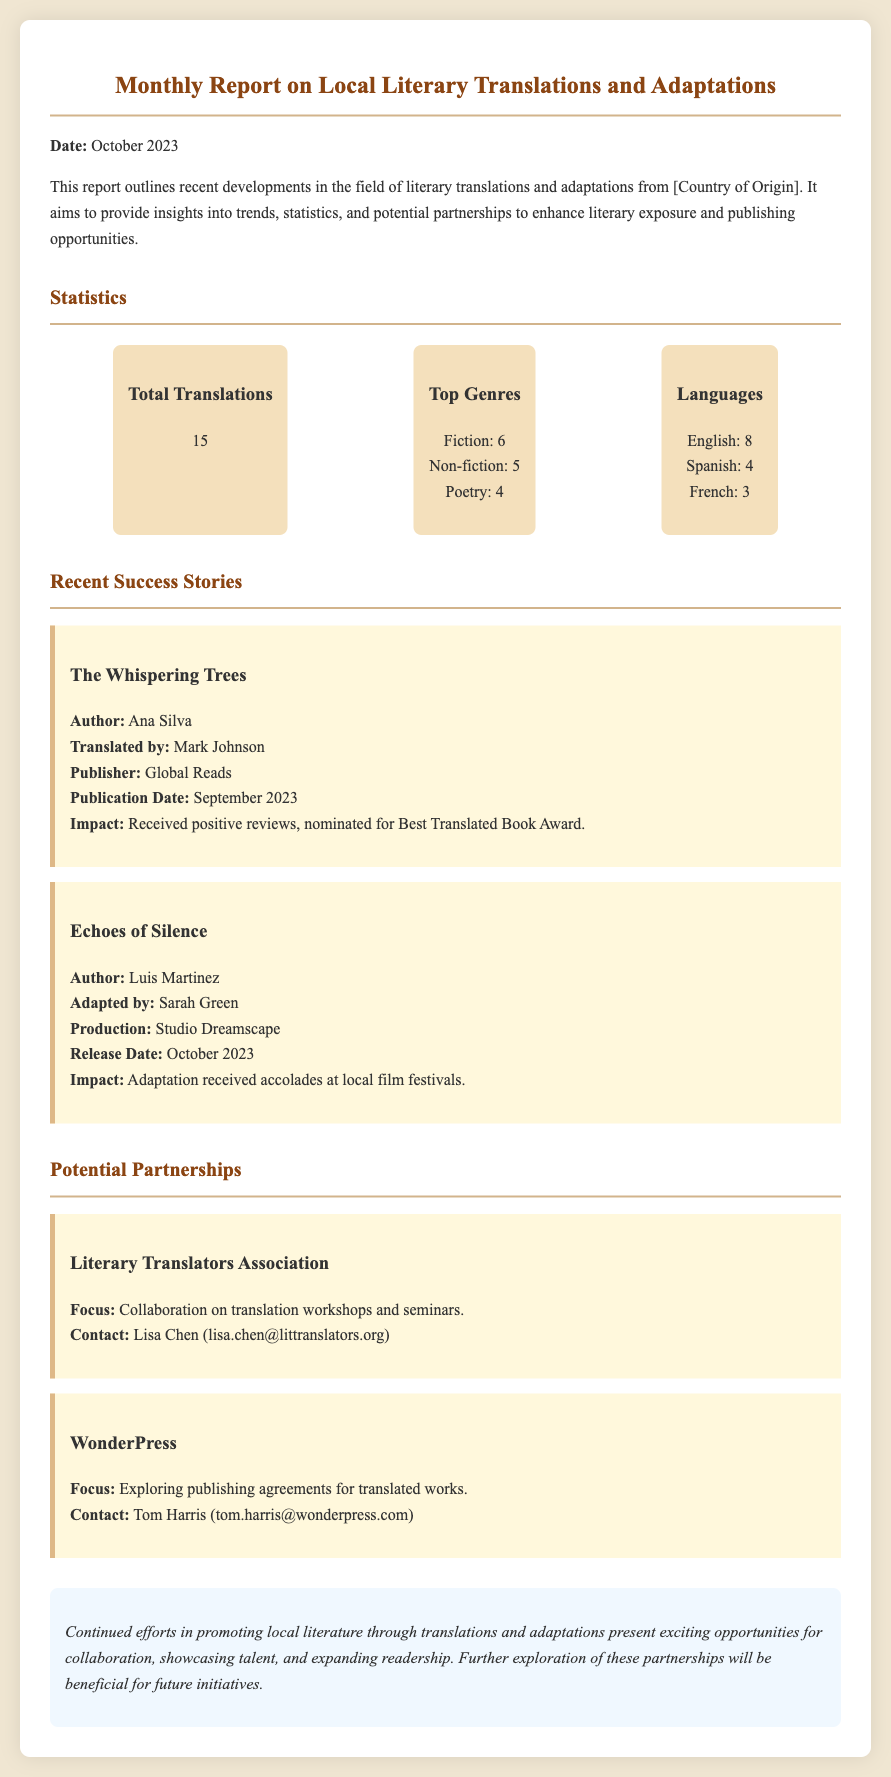What is the date of the report? The date of the report is stated at the beginning of the document, which is October 2023.
Answer: October 2023 How many total translations are reported? The total number of translations is highlighted in the statistics section, indicating there are 15 translations.
Answer: 15 Who is the author of "The Whispering Trees"? The author of "The Whispering Trees" is mentioned in the success stories section, where it states Ana Silva as the author.
Answer: Ana Silva What were the top genres reported? The top genres can be found in the statistics section, where it lists Fiction, Non-fiction, and Poetry along with their respective numbers.
Answer: Fiction, Non-fiction, Poetry Which organization is focused on translation workshops? The potential partnerships section specifies the Literary Translators Association, which is focused on collaboration on translation workshops.
Answer: Literary Translators Association What impact did "Echoes of Silence" receive? The impact of "Echoes of Silence" is noted in the success stories section, indicating it received accolades at local film festivals.
Answer: Accolades at local film festivals How many translations were in Spanish? The statistics detail the number of translations by language, indicating there are 4 translations in Spanish.
Answer: 4 Who can be contacted regarding WonderPress? The document provides contact information for WonderPress, listing Tom Harris as the contact person.
Answer: Tom Harris 